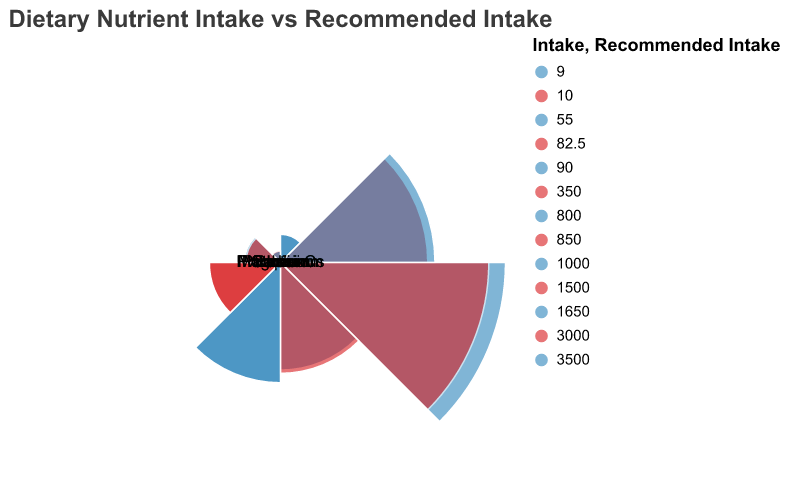what is the title of the plot? The title of the plot is displayed at the top and provides an overview of the visualized data.
Answer: Dietary Nutrient Intake vs Recommended Intake Which nutrient has the closest intake to the recommended intake in the plot? By comparing the values of intake and recommended intake for each nutrient, identify the nutrient with the smallest difference.
Answer: Calcium What are the intake values for Protein and Iron? The intake values are denoted by the radial distance of the arcs. Look at the arcs corresponding to Protein and Iron.
Answer: Protein: 55g, Iron: 10mg Which nutrient has the highest intake compared to its recommended intake? Look at the differences between intake and recommended intake values and determine the nutrient with the highest ratio of intake to recommended intake.
Answer: Potassium Which two nutrients have the recommended intake values closest to their actual intake values? Calculate the differences between intake and recommended intake for each nutrient and identify the two with the smallest differences.
Answer: Calcium and Magnesium How does the sodium intake compare to the recommended intake? Check the sodium section of the plot and compare its intake value to its recommended range.
Answer: Higher than the recommended intake What is the intake of Vitamin C compared to its recommended intake? Use the plot to compare the intake of Vitamin C with its recommended intake value.
Answer: Slightly higher than the recommended intake Which nutrient has the lowest intake value in the plot? Look at the arcs representing nutrient intakes and identify the one with the smallest radius.
Answer: Iron How do the intake values of Magnesium and Vitamin C compare? Compare the radial distances corresponding to the intake values of Magnesium and Vitamin C.
Answer: The same value What is the color used to represent recommended intake in the plot? Identify the color utilized to denote the recommended intake values in the visual representation.
Answer: Red 